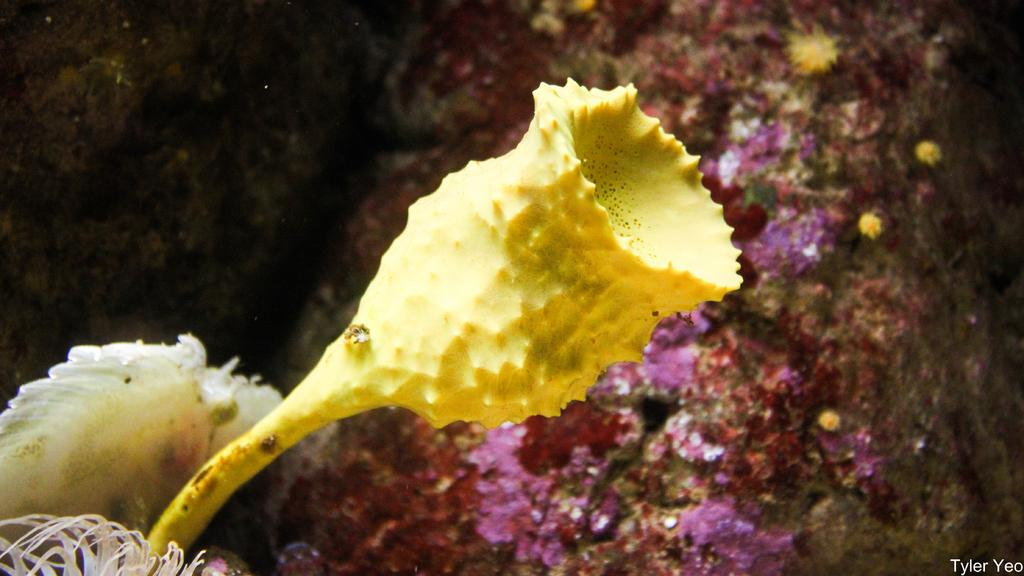What type of plants can be seen in the image? There are flowers in the image. What can be seen in the background of the image? There are rocks visible in the background of the image. In which direction are the flowers stretching in the image? The flowers do not stretch in the image; they are stationary plants. 